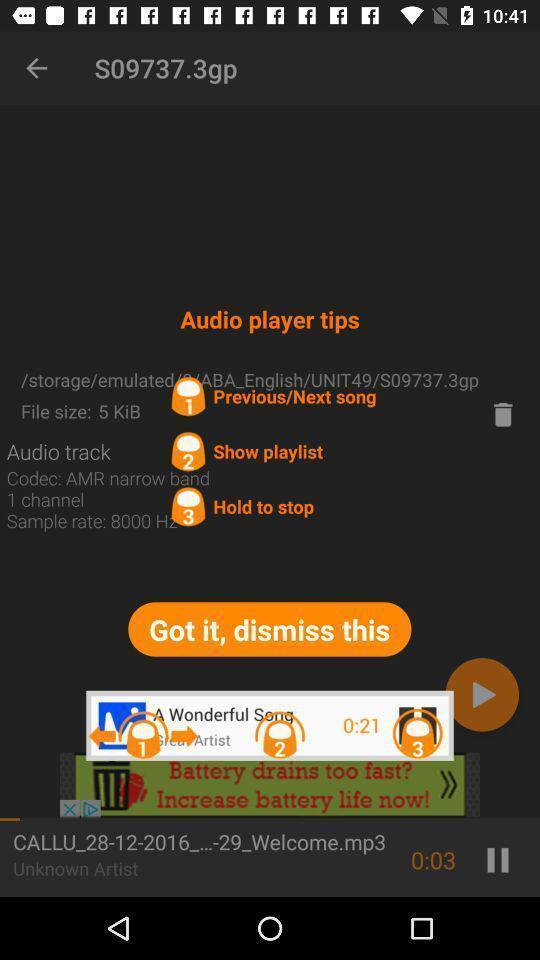Provide a detailed account of this screenshot. Screen displaying audio player tips. 